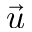<formula> <loc_0><loc_0><loc_500><loc_500>\vec { u }</formula> 